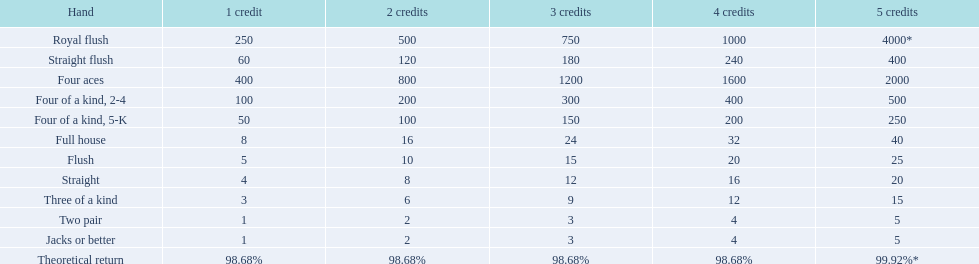Which hand is lower than straight flush? Four aces. Which hand is lower than four aces? Four of a kind, 2-4. Which hand is higher out of straight and flush? Flush. 